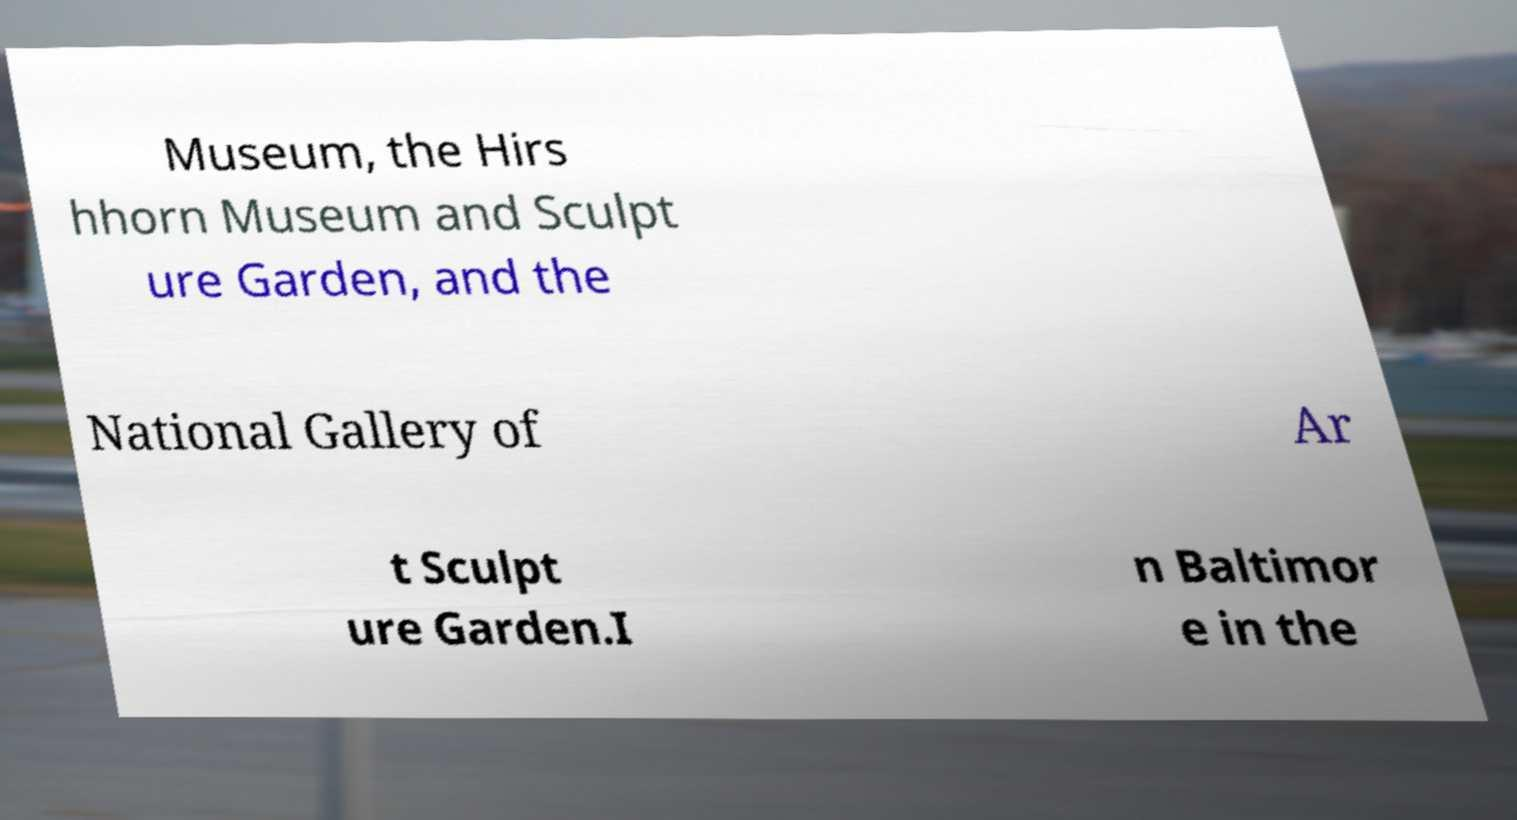I need the written content from this picture converted into text. Can you do that? Museum, the Hirs hhorn Museum and Sculpt ure Garden, and the National Gallery of Ar t Sculpt ure Garden.I n Baltimor e in the 